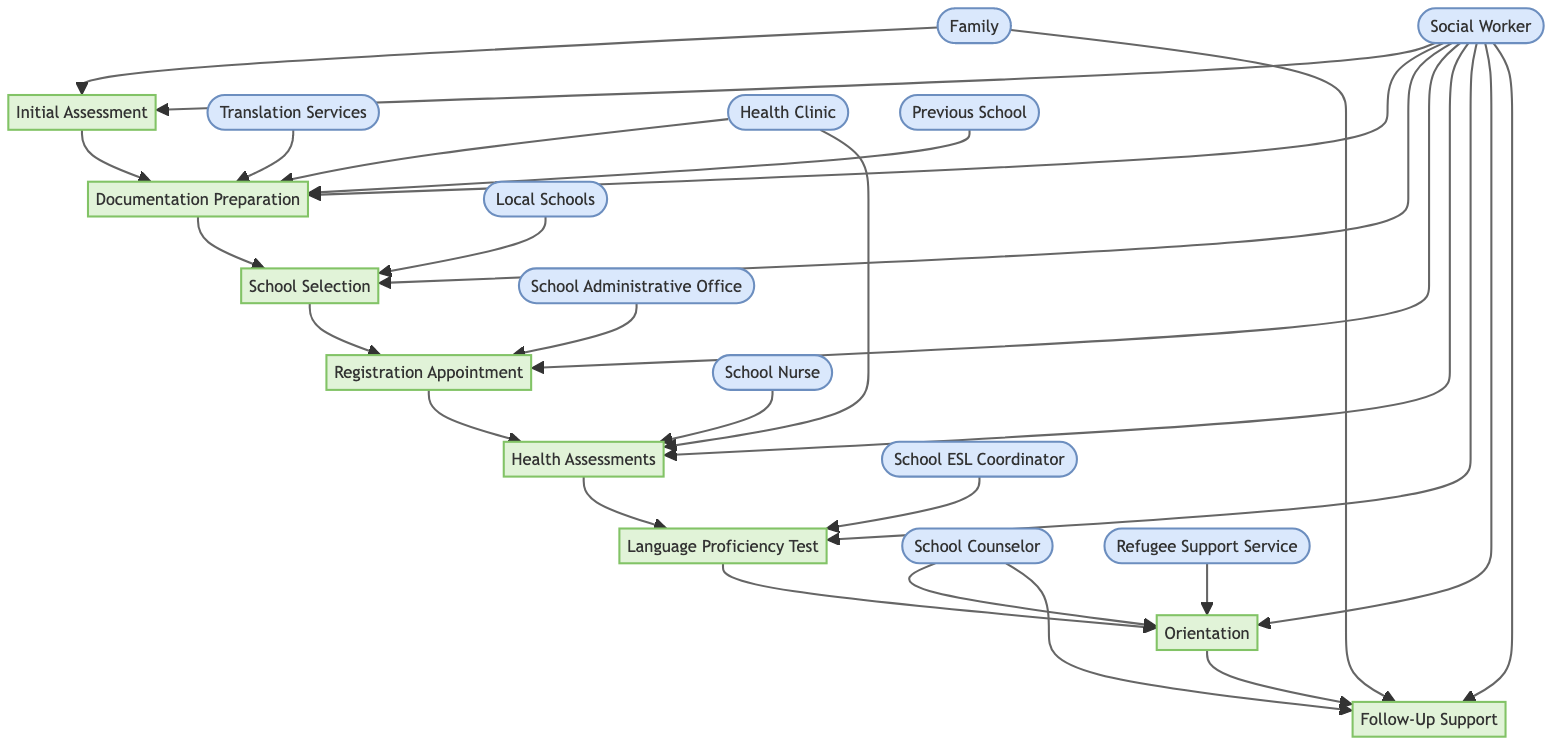what is the first step in the enrollment procedure? The first step is "Initial Assessment." This is identified at the top of the flowchart and shows the starting point of the procedure.
Answer: Initial Assessment how many steps are there in the procedure? By counting the nodes in the flowchart, we see there are a total of eight steps from "Initial Assessment" to "Follow-Up Support."
Answer: 8 which step involves translating and compiling documents? The step that involves translating and compiling documents is "Documentation Preparation," as indicated in the flowchart where this task is described.
Answer: Documentation Preparation who is responsible for scheduling the registration appointment? The "Social Worker" is responsible for scheduling the registration appointment, as shown in the flowchart where the Social Worker is linked to that step.
Answer: Social Worker which entities are involved in arranging health assessments? The entities involved in arranging health assessments are "Social Worker," "Health Clinic," and "School Nurse," as these are intertwined with the "Health Assessments" step in the flowchart.
Answer: Social Worker, Health Clinic, School Nurse what is the final step in the enrollment process? The final step in the enrollment process is "Follow-Up Support," located at the end of the flowchart, marking the completion of the procedure.
Answer: Follow-Up Support how does the process flow from health assessments to language proficiency test? The process flows from "Health Assessments" (step 5) to "Language Proficiency Test" (step 6) by following the arrows, indicating that after health assessments are done, the next action is to coordinate for a language proficiency test.
Answer: Health Assessments to Language Proficiency Test which step is concerned with research about local schools? The step concerned with research about local schools is "School Selection," which comes after documentation preparation as indicated in the flowchart.
Answer: School Selection what role does the School Counselor play in this procedure? The School Counselor is involved in both "Orientation" and "Follow-Up Support," and their inclusion in those steps indicates they play an essential role in helping the child and family adjust to the new school environment and monitor progress.
Answer: Orientation, Follow-Up Support 